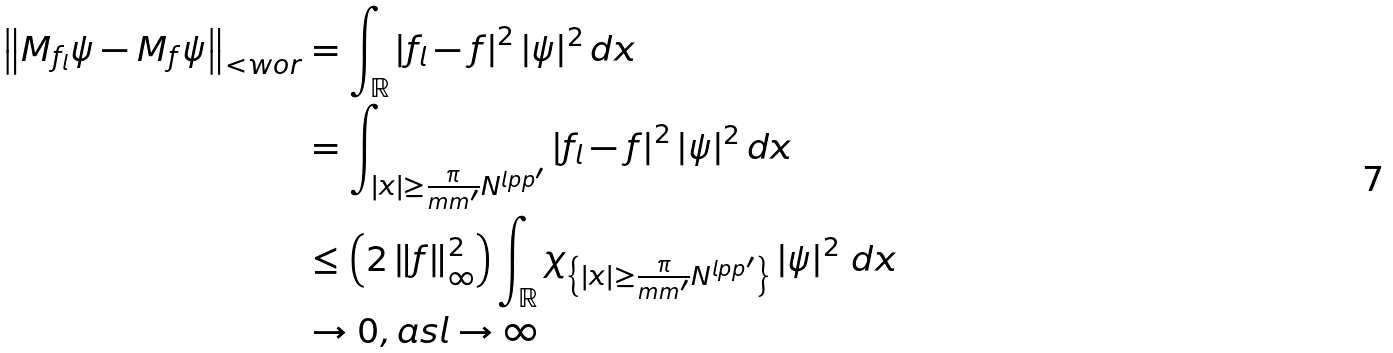<formula> <loc_0><loc_0><loc_500><loc_500>\left \| M _ { f _ { l } } \psi - M _ { f } \psi \right \| _ { < w o r } & = \int _ { \mathbb { R } } \left | f _ { l } - f \right | ^ { 2 } | \psi | ^ { 2 } \, d x \\ & = \int _ { | x | \geq \frac { \pi } { m m ^ { \prime } } N ^ { l p p ^ { \prime } } } \left | f _ { l } - f \right | ^ { 2 } | \psi | ^ { 2 } \, d x \\ & \leq \left ( 2 \left \| f \right \| _ { \infty } ^ { 2 } \right ) \int _ { \mathbb { R } } \chi _ { \left \{ | x | \geq \frac { \pi } { m m ^ { \prime } } N ^ { l p p ^ { \prime } } \right \} } \left | \psi \right | ^ { 2 } \, d x \\ & \rightarrow 0 , a s l \rightarrow \infty</formula> 